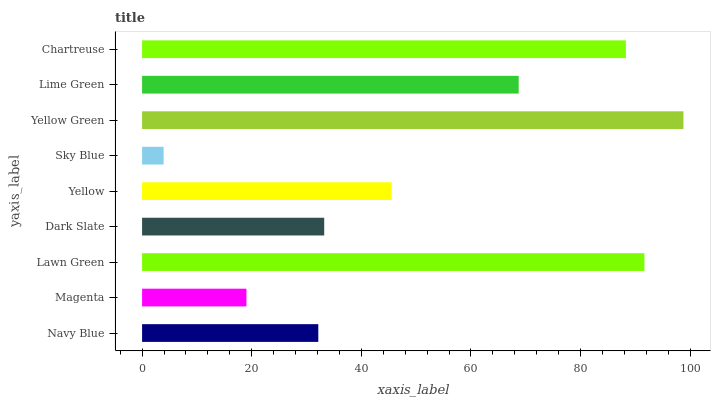Is Sky Blue the minimum?
Answer yes or no. Yes. Is Yellow Green the maximum?
Answer yes or no. Yes. Is Magenta the minimum?
Answer yes or no. No. Is Magenta the maximum?
Answer yes or no. No. Is Navy Blue greater than Magenta?
Answer yes or no. Yes. Is Magenta less than Navy Blue?
Answer yes or no. Yes. Is Magenta greater than Navy Blue?
Answer yes or no. No. Is Navy Blue less than Magenta?
Answer yes or no. No. Is Yellow the high median?
Answer yes or no. Yes. Is Yellow the low median?
Answer yes or no. Yes. Is Chartreuse the high median?
Answer yes or no. No. Is Dark Slate the low median?
Answer yes or no. No. 